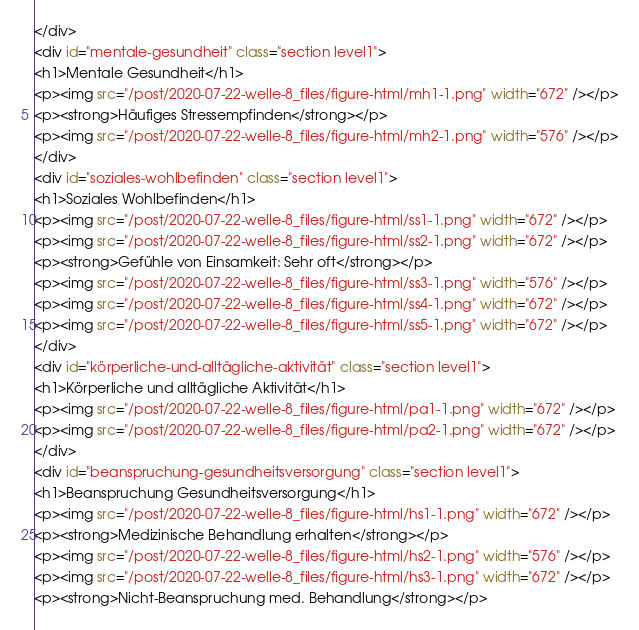<code> <loc_0><loc_0><loc_500><loc_500><_HTML_></div>
<div id="mentale-gesundheit" class="section level1">
<h1>Mentale Gesundheit</h1>
<p><img src="/post/2020-07-22-welle-8_files/figure-html/mh1-1.png" width="672" /></p>
<p><strong>Häufiges Stressempfinden</strong></p>
<p><img src="/post/2020-07-22-welle-8_files/figure-html/mh2-1.png" width="576" /></p>
</div>
<div id="soziales-wohlbefinden" class="section level1">
<h1>Soziales Wohlbefinden</h1>
<p><img src="/post/2020-07-22-welle-8_files/figure-html/ss1-1.png" width="672" /></p>
<p><img src="/post/2020-07-22-welle-8_files/figure-html/ss2-1.png" width="672" /></p>
<p><strong>Gefühle von Einsamkeit: Sehr oft</strong></p>
<p><img src="/post/2020-07-22-welle-8_files/figure-html/ss3-1.png" width="576" /></p>
<p><img src="/post/2020-07-22-welle-8_files/figure-html/ss4-1.png" width="672" /></p>
<p><img src="/post/2020-07-22-welle-8_files/figure-html/ss5-1.png" width="672" /></p>
</div>
<div id="körperliche-und-alltägliche-aktivität" class="section level1">
<h1>Körperliche und alltägliche Aktivität</h1>
<p><img src="/post/2020-07-22-welle-8_files/figure-html/pa1-1.png" width="672" /></p>
<p><img src="/post/2020-07-22-welle-8_files/figure-html/pa2-1.png" width="672" /></p>
</div>
<div id="beanspruchung-gesundheitsversorgung" class="section level1">
<h1>Beanspruchung Gesundheitsversorgung</h1>
<p><img src="/post/2020-07-22-welle-8_files/figure-html/hs1-1.png" width="672" /></p>
<p><strong>Medizinische Behandlung erhalten</strong></p>
<p><img src="/post/2020-07-22-welle-8_files/figure-html/hs2-1.png" width="576" /></p>
<p><img src="/post/2020-07-22-welle-8_files/figure-html/hs3-1.png" width="672" /></p>
<p><strong>Nicht-Beanspruchung med. Behandlung</strong></p></code> 